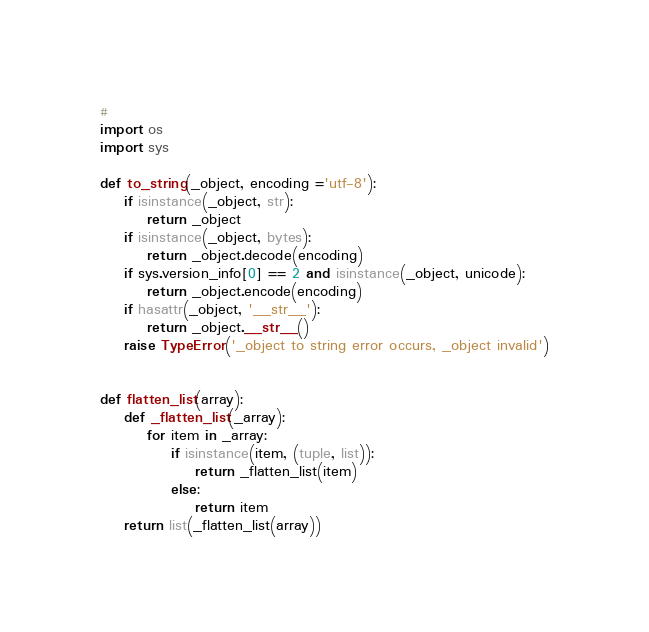<code> <loc_0><loc_0><loc_500><loc_500><_Python_>#
import os
import sys

def to_string(_object, encoding ='utf-8'):
    if isinstance(_object, str):
        return _object
    if isinstance(_object, bytes):
        return _object.decode(encoding)
    if sys.version_info[0] == 2 and isinstance(_object, unicode):
        return _object.encode(encoding)
    if hasattr(_object, '__str__'):
        return _object.__str__()
    raise TypeError('_object to string error occurs, _object invalid')


def flatten_list(array):
    def _flatten_list(_array):
        for item in _array:
            if isinstance(item, (tuple, list)):
                return _flatten_list(item)
            else:
                return item
    return list(_flatten_list(array))

</code> 